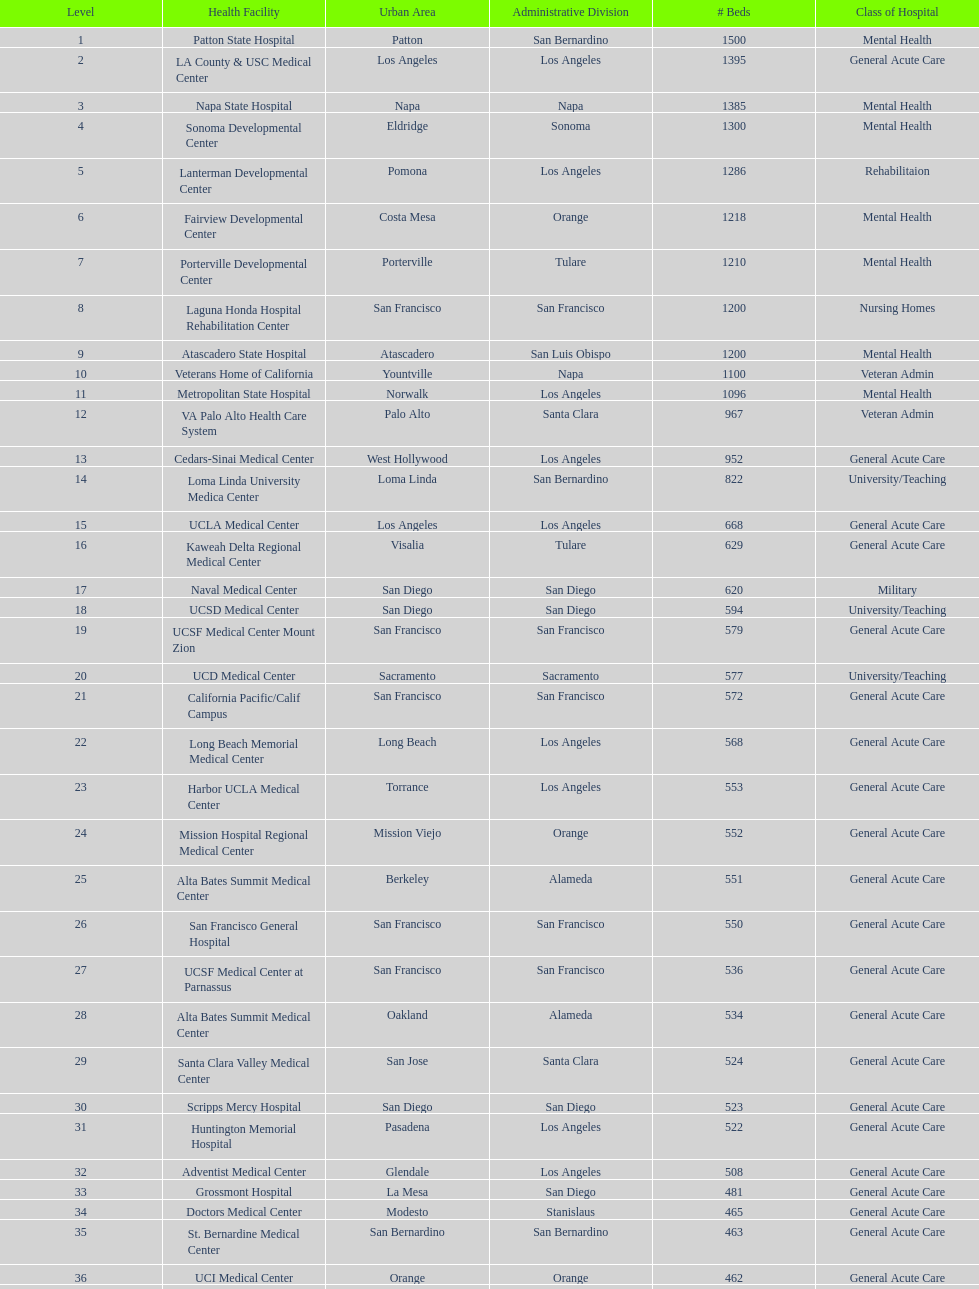What hospital in los angeles county providing hospital beds specifically for rehabilitation is ranked at least among the top 10 hospitals? Lanterman Developmental Center. 